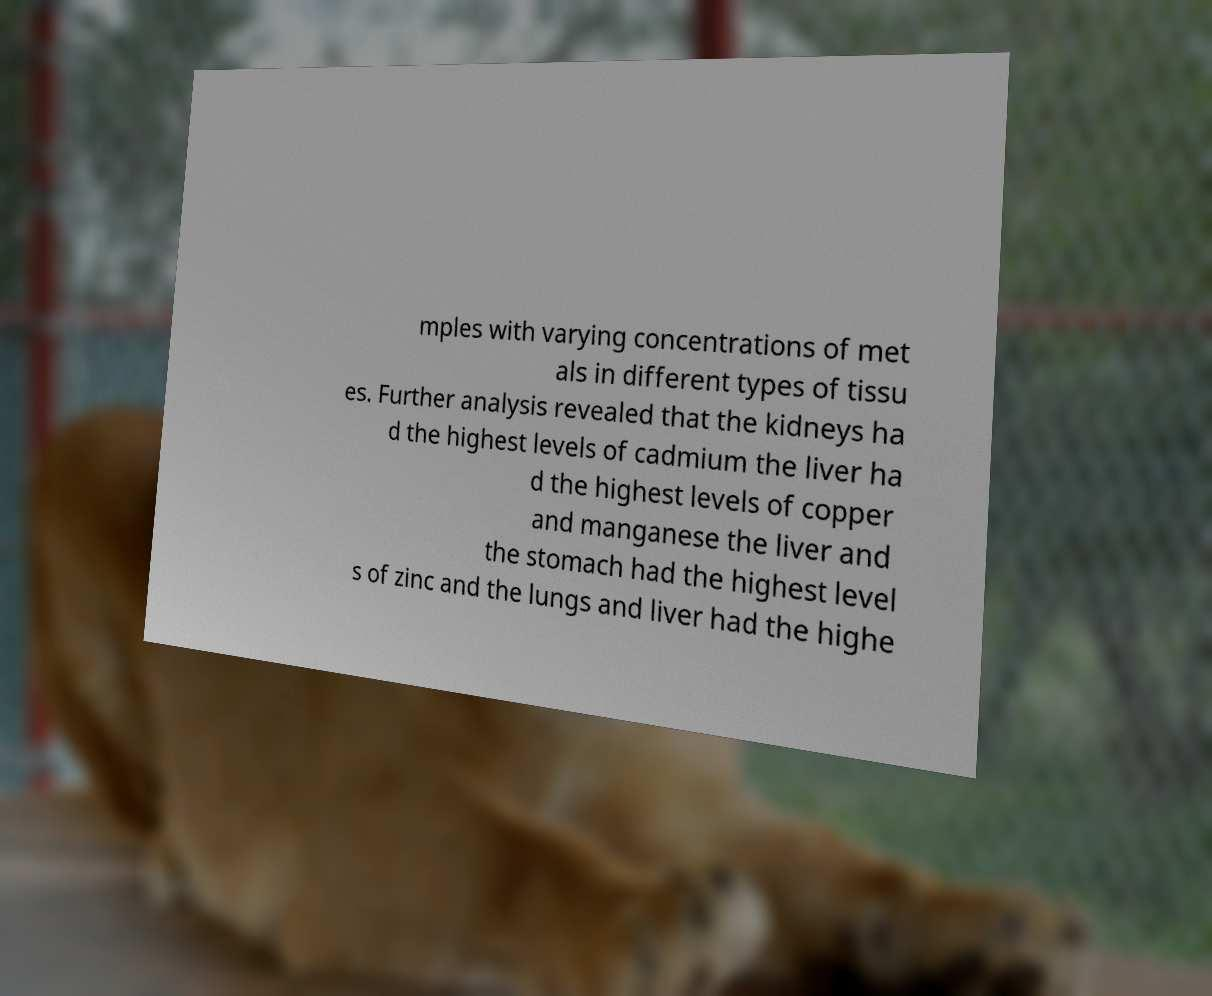What messages or text are displayed in this image? I need them in a readable, typed format. mples with varying concentrations of met als in different types of tissu es. Further analysis revealed that the kidneys ha d the highest levels of cadmium the liver ha d the highest levels of copper and manganese the liver and the stomach had the highest level s of zinc and the lungs and liver had the highe 